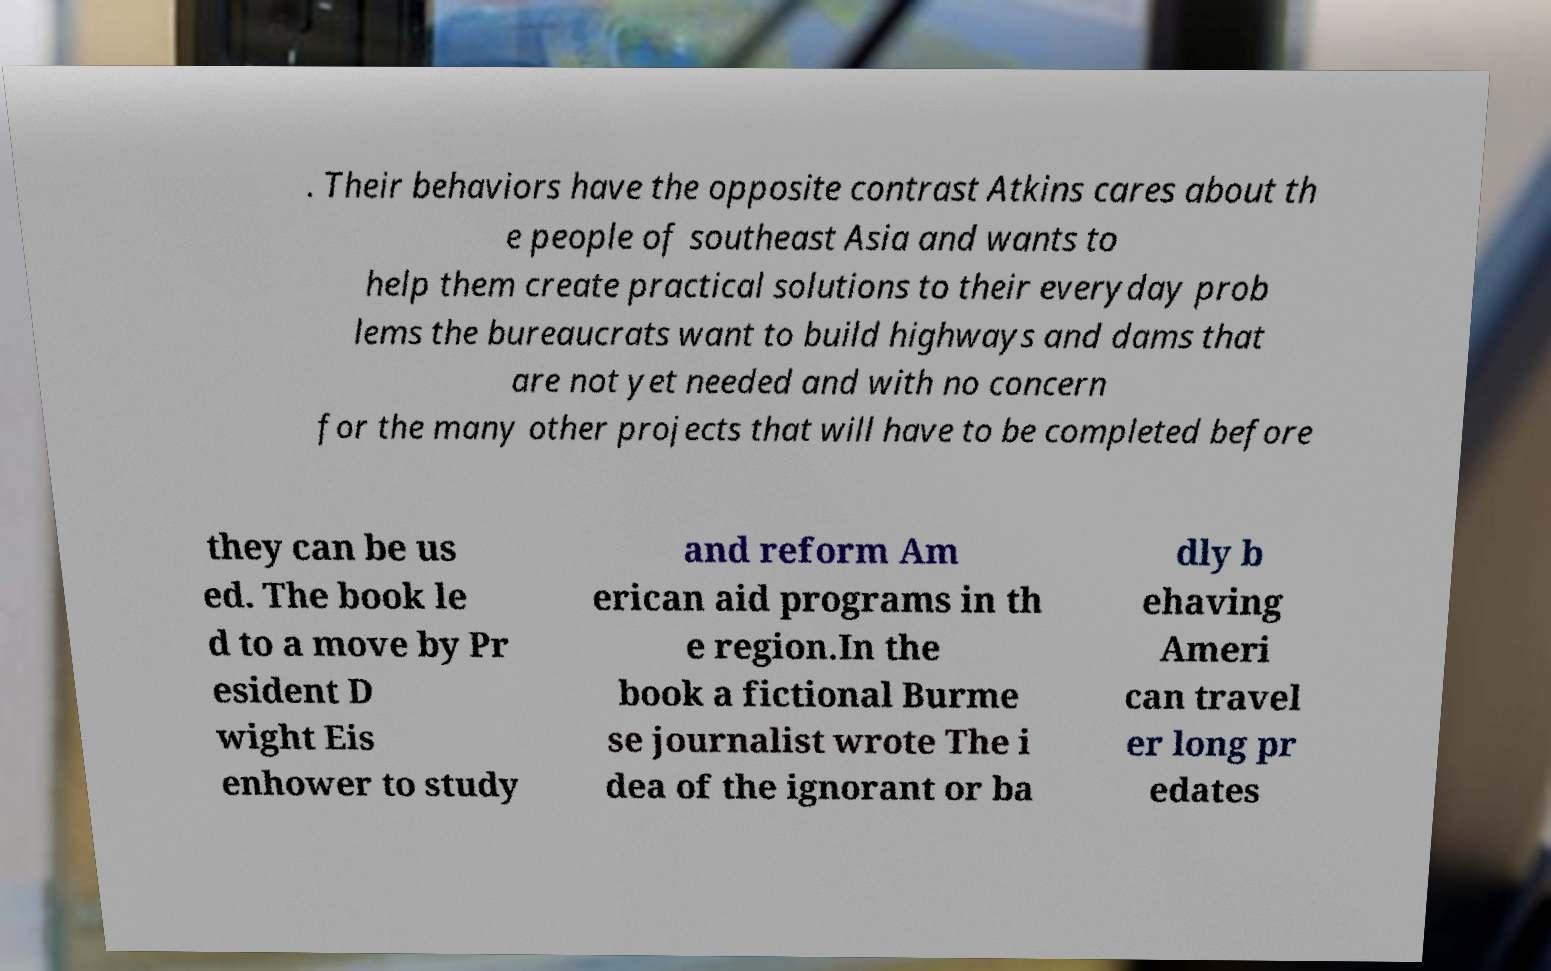Could you assist in decoding the text presented in this image and type it out clearly? . Their behaviors have the opposite contrast Atkins cares about th e people of southeast Asia and wants to help them create practical solutions to their everyday prob lems the bureaucrats want to build highways and dams that are not yet needed and with no concern for the many other projects that will have to be completed before they can be us ed. The book le d to a move by Pr esident D wight Eis enhower to study and reform Am erican aid programs in th e region.In the book a fictional Burme se journalist wrote The i dea of the ignorant or ba dly b ehaving Ameri can travel er long pr edates 